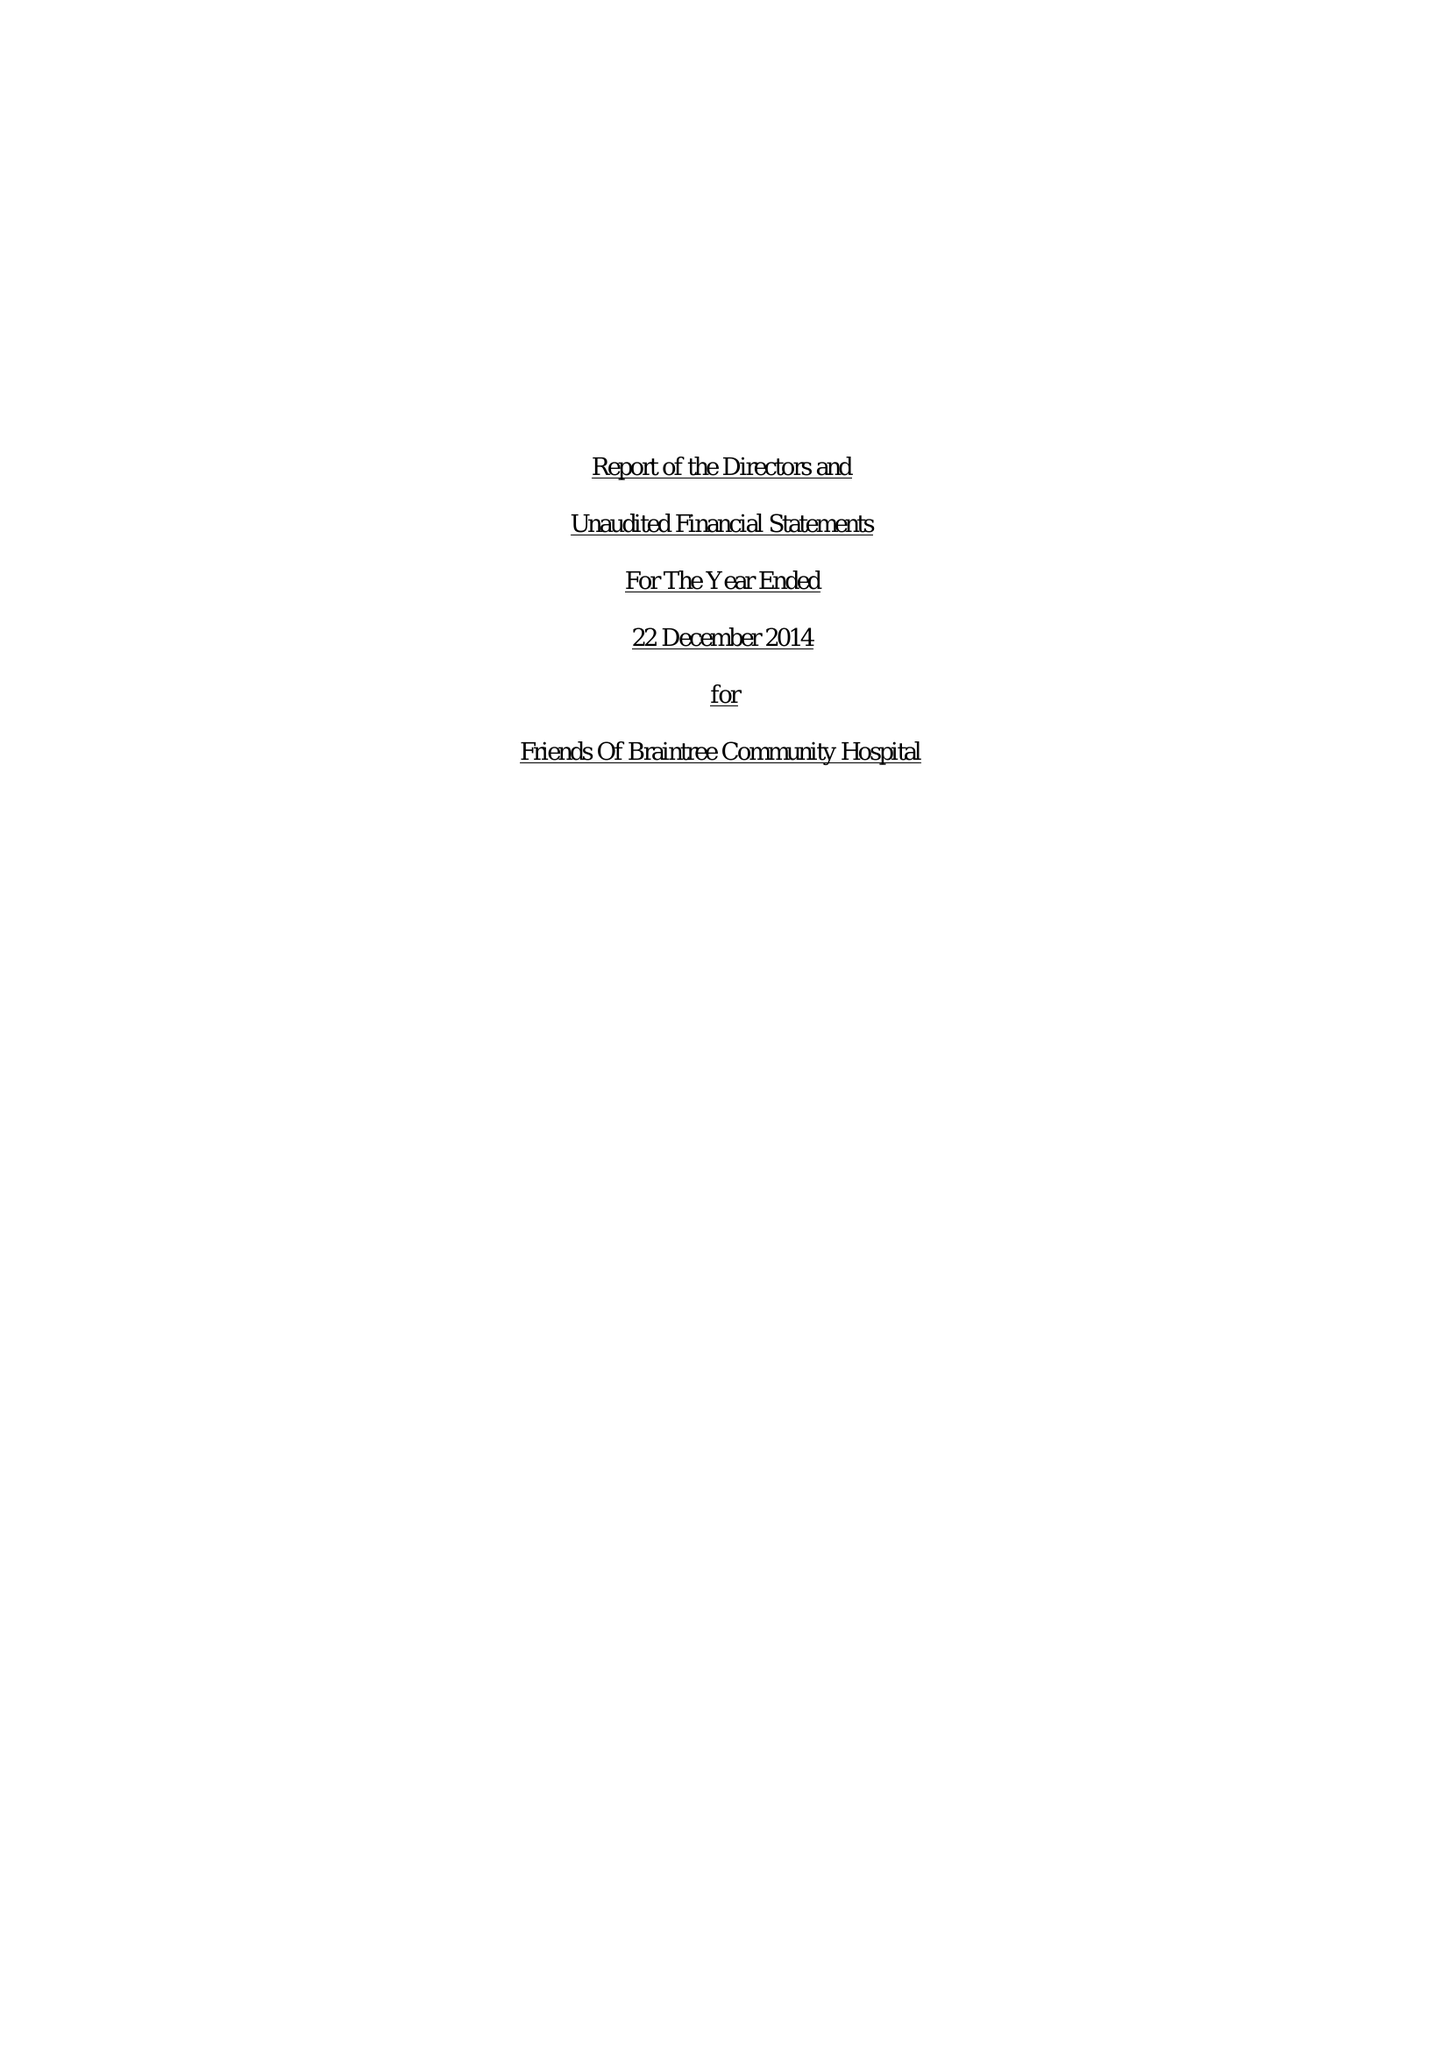What is the value for the address__post_town?
Answer the question using a single word or phrase. BRAINTREE 